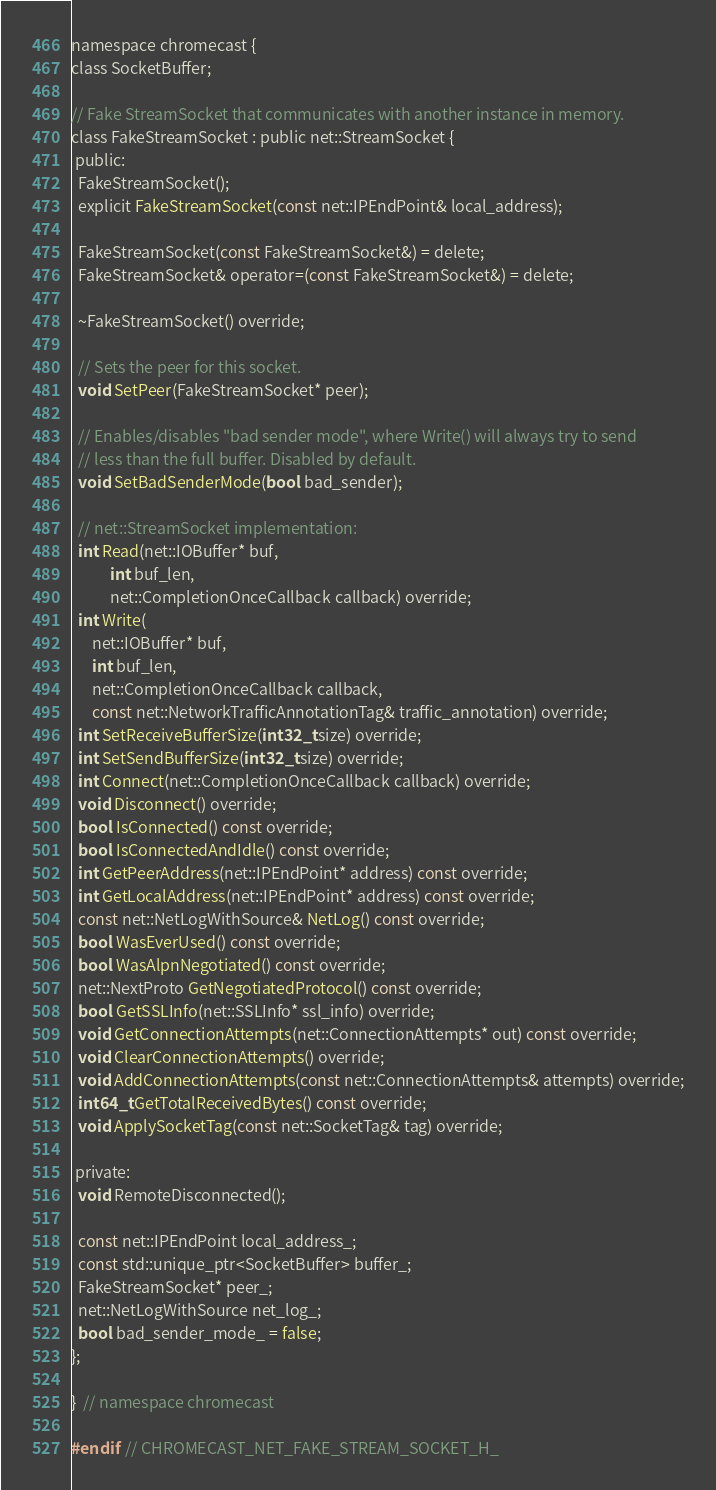<code> <loc_0><loc_0><loc_500><loc_500><_C_>namespace chromecast {
class SocketBuffer;

// Fake StreamSocket that communicates with another instance in memory.
class FakeStreamSocket : public net::StreamSocket {
 public:
  FakeStreamSocket();
  explicit FakeStreamSocket(const net::IPEndPoint& local_address);

  FakeStreamSocket(const FakeStreamSocket&) = delete;
  FakeStreamSocket& operator=(const FakeStreamSocket&) = delete;

  ~FakeStreamSocket() override;

  // Sets the peer for this socket.
  void SetPeer(FakeStreamSocket* peer);

  // Enables/disables "bad sender mode", where Write() will always try to send
  // less than the full buffer. Disabled by default.
  void SetBadSenderMode(bool bad_sender);

  // net::StreamSocket implementation:
  int Read(net::IOBuffer* buf,
           int buf_len,
           net::CompletionOnceCallback callback) override;
  int Write(
      net::IOBuffer* buf,
      int buf_len,
      net::CompletionOnceCallback callback,
      const net::NetworkTrafficAnnotationTag& traffic_annotation) override;
  int SetReceiveBufferSize(int32_t size) override;
  int SetSendBufferSize(int32_t size) override;
  int Connect(net::CompletionOnceCallback callback) override;
  void Disconnect() override;
  bool IsConnected() const override;
  bool IsConnectedAndIdle() const override;
  int GetPeerAddress(net::IPEndPoint* address) const override;
  int GetLocalAddress(net::IPEndPoint* address) const override;
  const net::NetLogWithSource& NetLog() const override;
  bool WasEverUsed() const override;
  bool WasAlpnNegotiated() const override;
  net::NextProto GetNegotiatedProtocol() const override;
  bool GetSSLInfo(net::SSLInfo* ssl_info) override;
  void GetConnectionAttempts(net::ConnectionAttempts* out) const override;
  void ClearConnectionAttempts() override;
  void AddConnectionAttempts(const net::ConnectionAttempts& attempts) override;
  int64_t GetTotalReceivedBytes() const override;
  void ApplySocketTag(const net::SocketTag& tag) override;

 private:
  void RemoteDisconnected();

  const net::IPEndPoint local_address_;
  const std::unique_ptr<SocketBuffer> buffer_;
  FakeStreamSocket* peer_;
  net::NetLogWithSource net_log_;
  bool bad_sender_mode_ = false;
};

}  // namespace chromecast

#endif  // CHROMECAST_NET_FAKE_STREAM_SOCKET_H_
</code> 